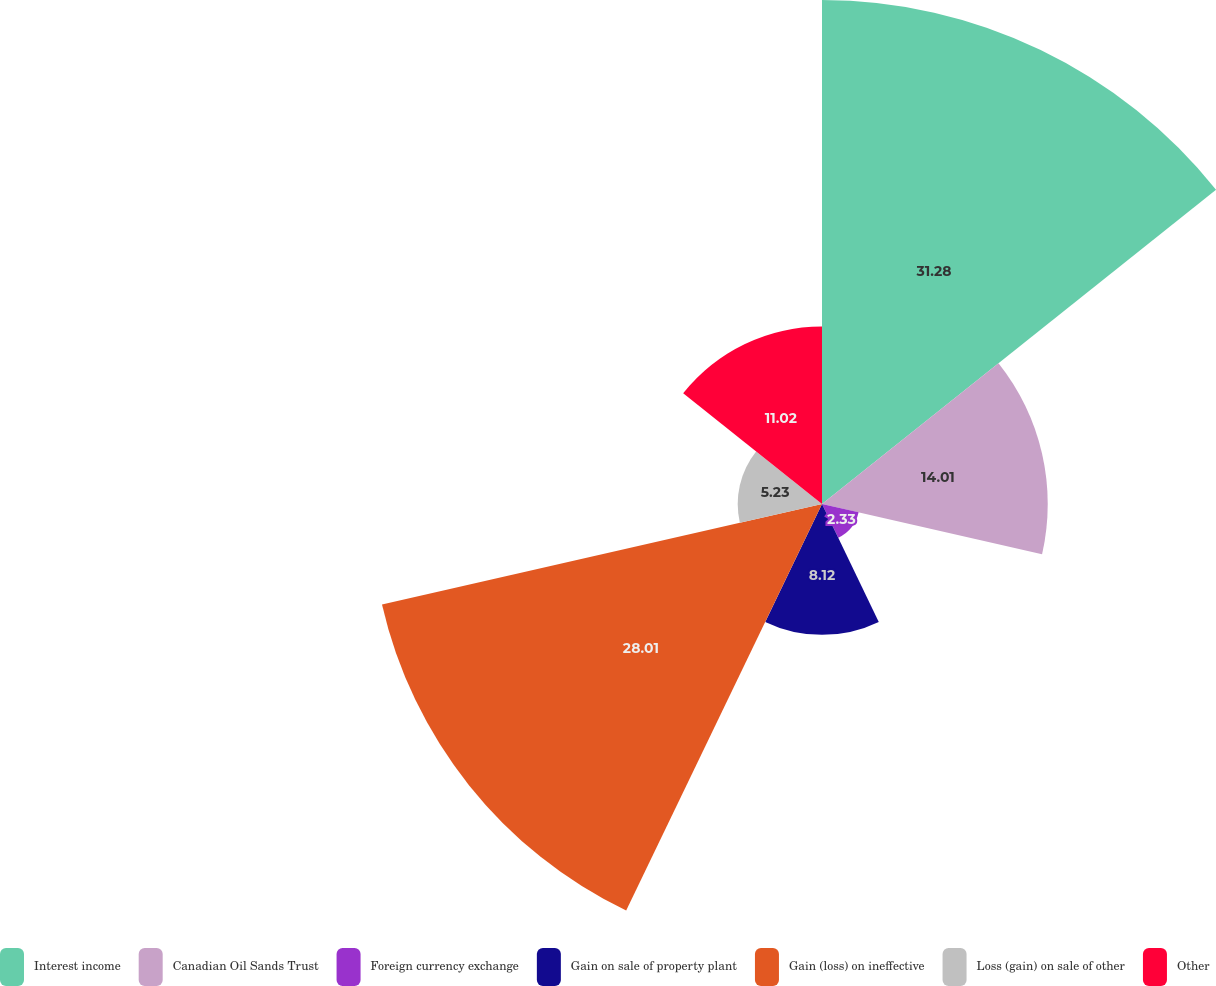Convert chart to OTSL. <chart><loc_0><loc_0><loc_500><loc_500><pie_chart><fcel>Interest income<fcel>Canadian Oil Sands Trust<fcel>Foreign currency exchange<fcel>Gain on sale of property plant<fcel>Gain (loss) on ineffective<fcel>Loss (gain) on sale of other<fcel>Other<nl><fcel>31.28%<fcel>14.01%<fcel>2.33%<fcel>8.12%<fcel>28.01%<fcel>5.23%<fcel>11.02%<nl></chart> 